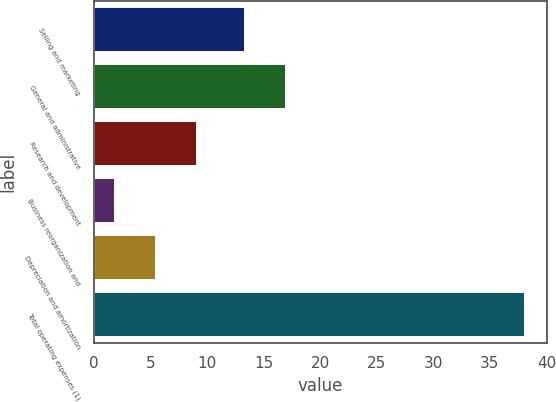<chart> <loc_0><loc_0><loc_500><loc_500><bar_chart><fcel>Selling and marketing<fcel>General and administrative<fcel>Research and development<fcel>Business reorganization and<fcel>Depreciation and amortization<fcel>Total operating expenses (1)<nl><fcel>13.3<fcel>16.93<fcel>9.06<fcel>1.8<fcel>5.43<fcel>38.1<nl></chart> 